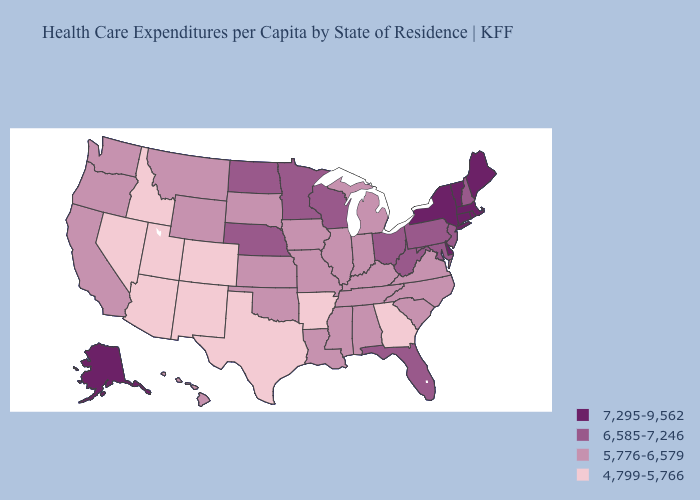Does Pennsylvania have the lowest value in the USA?
Write a very short answer. No. What is the highest value in the Northeast ?
Concise answer only. 7,295-9,562. Name the states that have a value in the range 4,799-5,766?
Quick response, please. Arizona, Arkansas, Colorado, Georgia, Idaho, Nevada, New Mexico, Texas, Utah. What is the value of Montana?
Keep it brief. 5,776-6,579. Does Massachusetts have a lower value than Georgia?
Concise answer only. No. Name the states that have a value in the range 7,295-9,562?
Concise answer only. Alaska, Connecticut, Delaware, Maine, Massachusetts, New York, Rhode Island, Vermont. Does Wisconsin have the highest value in the USA?
Short answer required. No. Name the states that have a value in the range 7,295-9,562?
Give a very brief answer. Alaska, Connecticut, Delaware, Maine, Massachusetts, New York, Rhode Island, Vermont. What is the value of Delaware?
Write a very short answer. 7,295-9,562. What is the value of Pennsylvania?
Short answer required. 6,585-7,246. Among the states that border Kentucky , which have the highest value?
Quick response, please. Ohio, West Virginia. Name the states that have a value in the range 5,776-6,579?
Give a very brief answer. Alabama, California, Hawaii, Illinois, Indiana, Iowa, Kansas, Kentucky, Louisiana, Michigan, Mississippi, Missouri, Montana, North Carolina, Oklahoma, Oregon, South Carolina, South Dakota, Tennessee, Virginia, Washington, Wyoming. Name the states that have a value in the range 7,295-9,562?
Answer briefly. Alaska, Connecticut, Delaware, Maine, Massachusetts, New York, Rhode Island, Vermont. What is the value of Nebraska?
Short answer required. 6,585-7,246. 